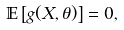<formula> <loc_0><loc_0><loc_500><loc_500>\mathbb { E } \left [ g ( X , \theta ) \right ] = 0 ,</formula> 